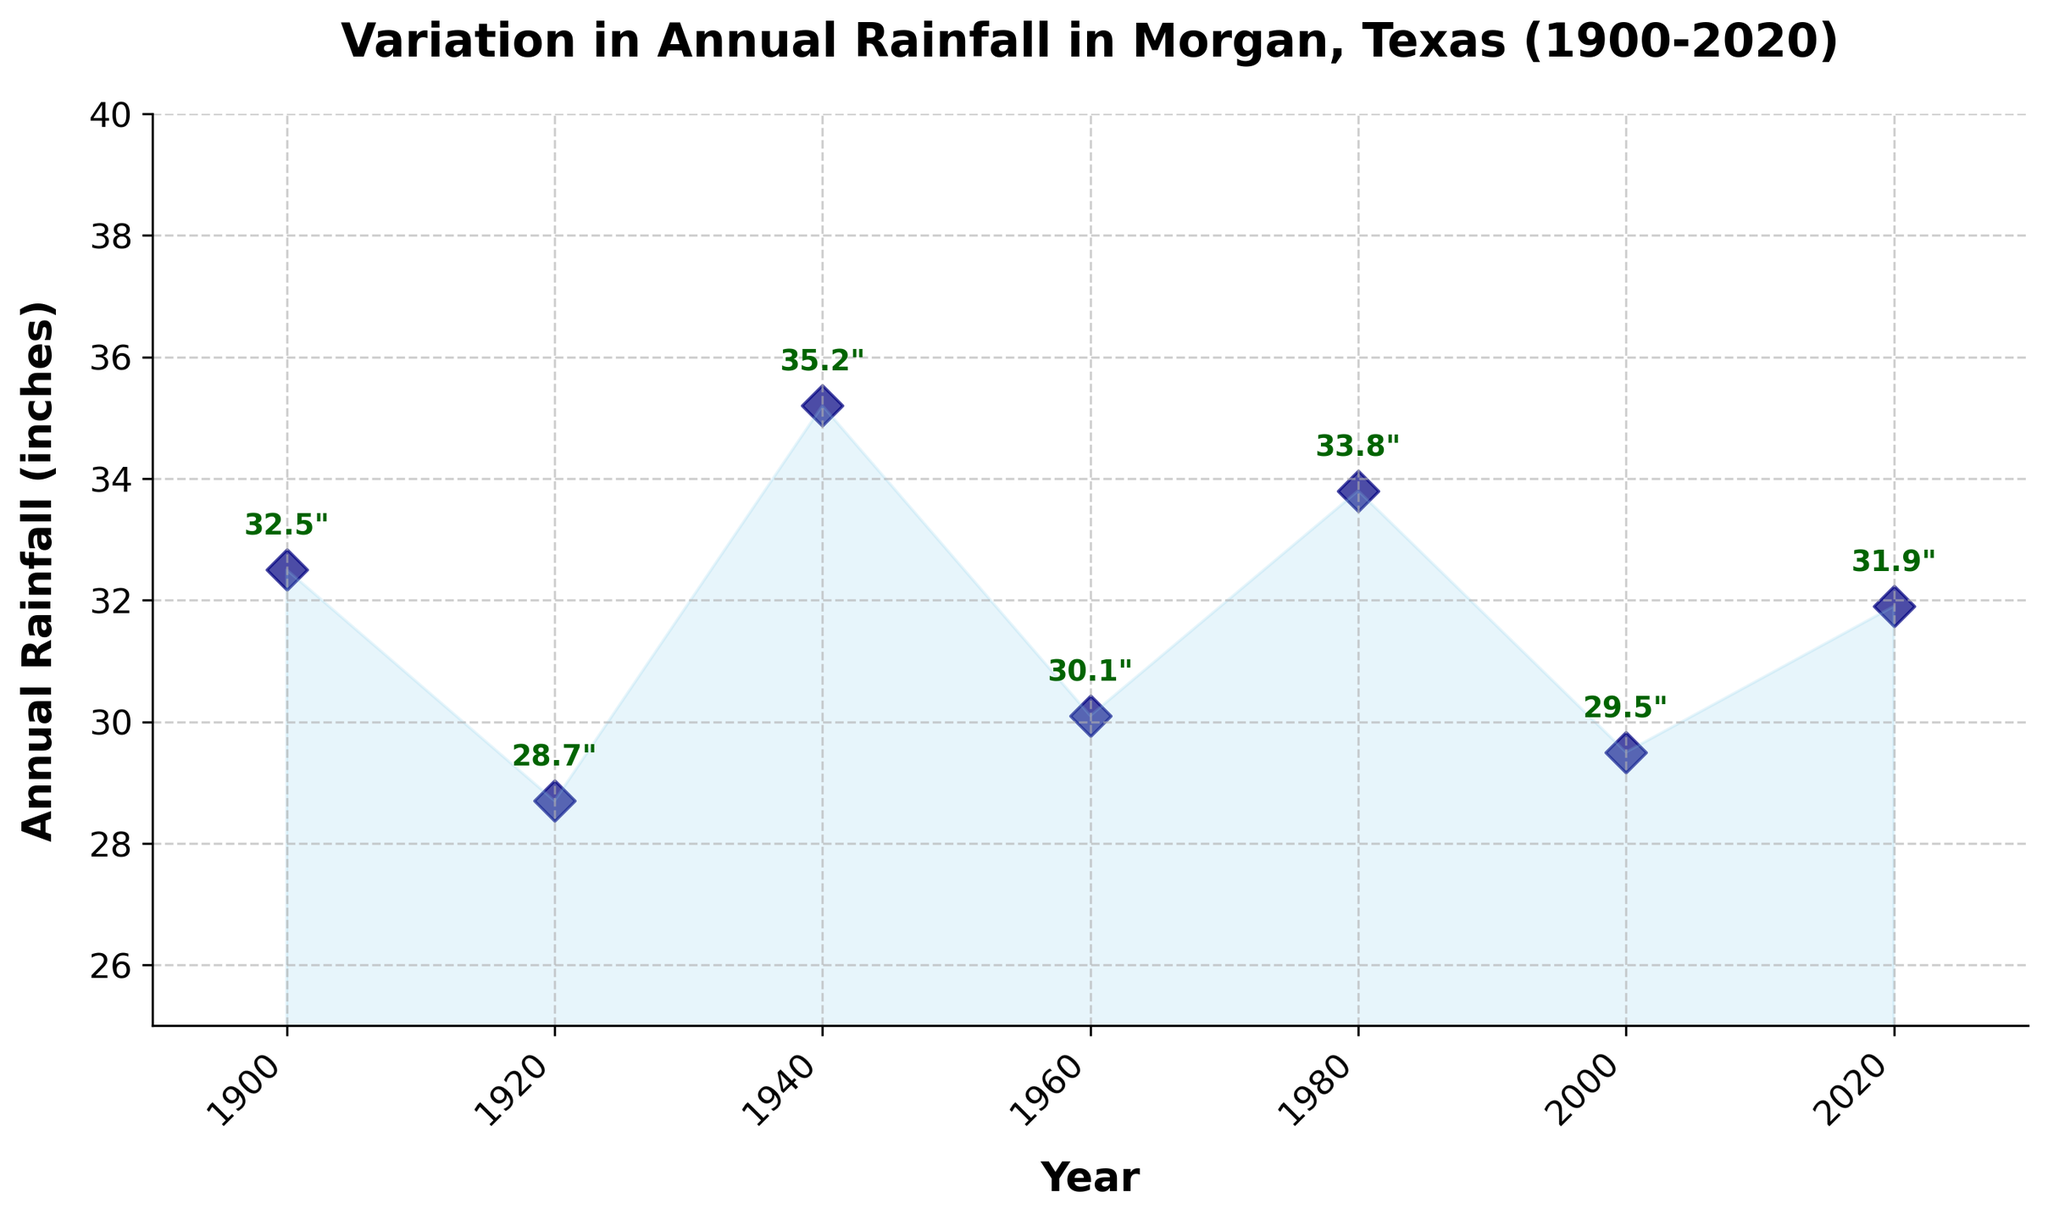what is the title of the plot? The title typically appears at the top of the plot. In this figure, it is written in bold and large fonts for better visibility.
Answer: Variation in Annual Rainfall in Morgan, Texas (1900-2020) How many data points are shown in the plot? We can count the number of diamonds (markers) present in the figure, each representing an individual data point. There are 7 markers visible.
Answer: 7 Which year had the highest annual rainfall? Looking at the vertical position of the markers, the highest one is around the year 1940. The rainfall value associated with this year is labeled as 35.2".
Answer: 1940 Which two years had the closest annual rainfall? Observing the labeled rainfall values, the years with quite similar values are 1900 (32.5") and 2020 (31.9"), showing only a 0.6 inches difference.
Answer: 1900 and 2020 What do the colors and shapes of the markers represent? The plot uses navy diamond shapes as markers, with a consistent color and shape throughout, to indicate uniform data representation for each year. These choices improve visual clarity.
Answer: They indicate uniform data representation How does the annual rainfall in 1980 compare to that in 2000? The plot shows the rainfall for 1980 as 33.8 inches and for 2000 as 29.5 inches. Thus, the rainfall in 1980 is greater than in 2000.
Answer: It is higher in 1980 What is the average annual rainfall from the years shown? Adding up the rainfall amounts (32.5 + 28.7 + 35.2 + 30.1 + 33.8 + 29.5 + 31.9) gives 221.7. Dividing by 7 (the number of data points), the average is 31.67 inches.
Answer: 31.67 inches Which decade experienced the most significant change in annual rainfall? Comparing the differences between consecutive decades, the change from 2000 (29.5") to 2020 (31.9") at 2.4 inches appears to be the largest.
Answer: 2000-2020 What rainfall value is labeled above the marker for the year 1960? The label above the marker of 1960 reads 30.1", indicating the annual rainfall for that year.
Answer: 30.1 inches 